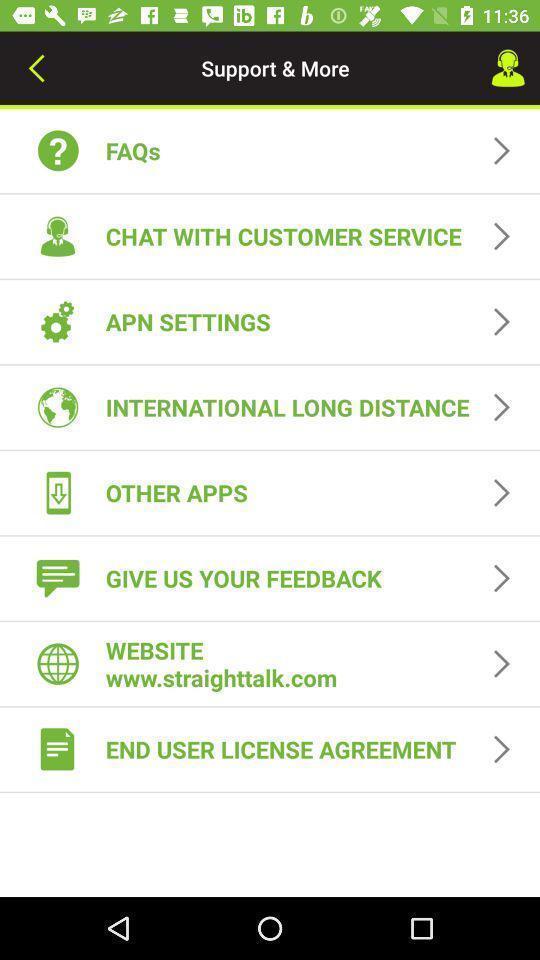Summarize the main components in this picture. Screen showing list of various for an app. 